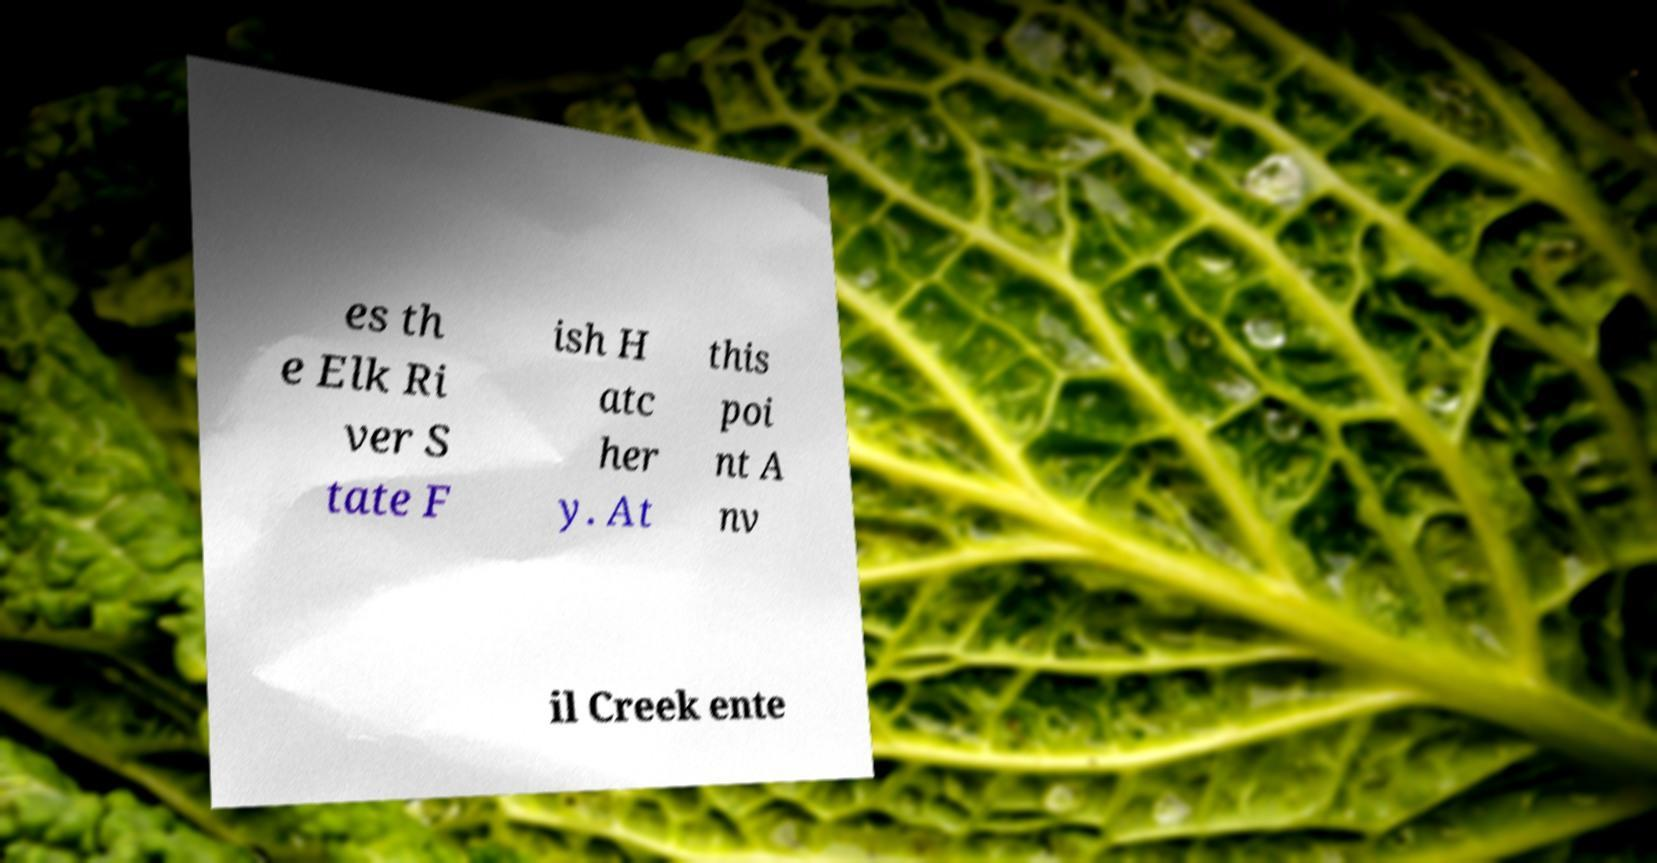Could you extract and type out the text from this image? es th e Elk Ri ver S tate F ish H atc her y. At this poi nt A nv il Creek ente 